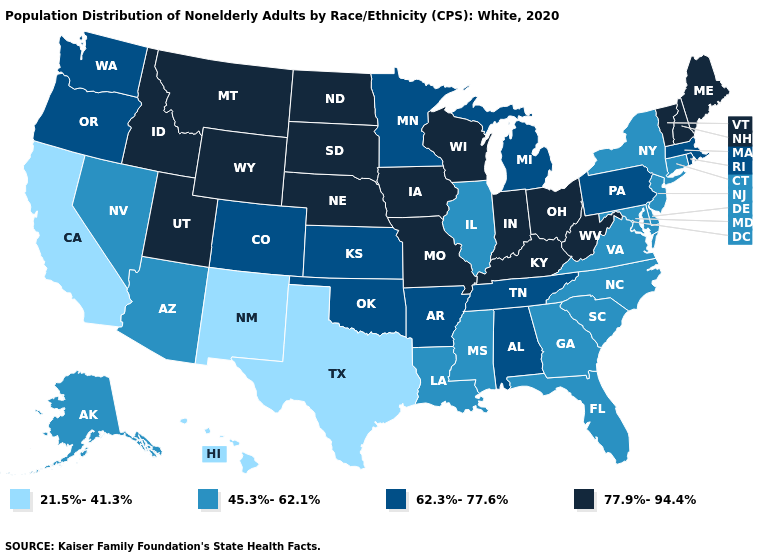Does Montana have the lowest value in the West?
Write a very short answer. No. What is the value of Hawaii?
Quick response, please. 21.5%-41.3%. Does the first symbol in the legend represent the smallest category?
Write a very short answer. Yes. What is the value of Missouri?
Write a very short answer. 77.9%-94.4%. What is the highest value in states that border Kentucky?
Be succinct. 77.9%-94.4%. What is the value of Tennessee?
Concise answer only. 62.3%-77.6%. Name the states that have a value in the range 21.5%-41.3%?
Short answer required. California, Hawaii, New Mexico, Texas. What is the value of Iowa?
Write a very short answer. 77.9%-94.4%. Does Vermont have a lower value than Maryland?
Be succinct. No. What is the lowest value in the USA?
Quick response, please. 21.5%-41.3%. Among the states that border Vermont , which have the highest value?
Keep it brief. New Hampshire. What is the value of Delaware?
Write a very short answer. 45.3%-62.1%. What is the lowest value in the USA?
Give a very brief answer. 21.5%-41.3%. Among the states that border Utah , does Nevada have the highest value?
Quick response, please. No. 